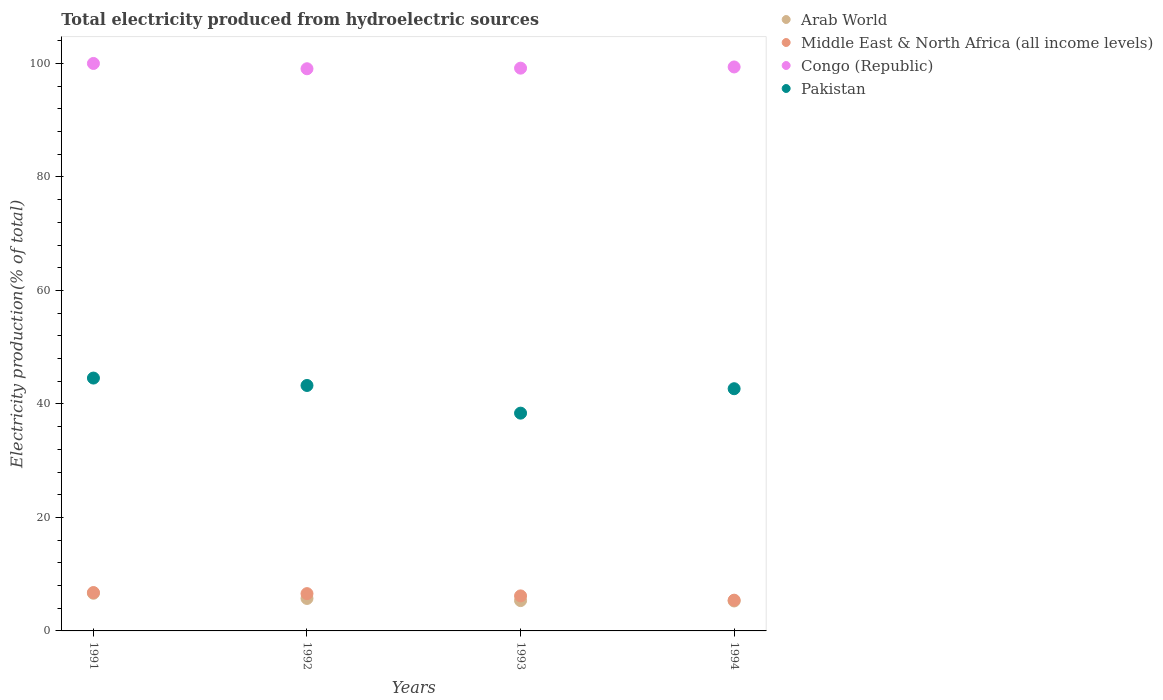How many different coloured dotlines are there?
Your answer should be very brief. 4. Is the number of dotlines equal to the number of legend labels?
Make the answer very short. Yes. What is the total electricity produced in Arab World in 1992?
Your answer should be compact. 5.72. Across all years, what is the maximum total electricity produced in Pakistan?
Ensure brevity in your answer.  44.56. Across all years, what is the minimum total electricity produced in Arab World?
Offer a very short reply. 5.28. In which year was the total electricity produced in Arab World maximum?
Make the answer very short. 1991. In which year was the total electricity produced in Middle East & North Africa (all income levels) minimum?
Ensure brevity in your answer.  1994. What is the total total electricity produced in Middle East & North Africa (all income levels) in the graph?
Offer a terse response. 24.93. What is the difference between the total electricity produced in Pakistan in 1992 and that in 1993?
Your response must be concise. 4.88. What is the difference between the total electricity produced in Congo (Republic) in 1993 and the total electricity produced in Pakistan in 1992?
Your answer should be compact. 55.92. What is the average total electricity produced in Pakistan per year?
Give a very brief answer. 42.22. In the year 1991, what is the difference between the total electricity produced in Congo (Republic) and total electricity produced in Middle East & North Africa (all income levels)?
Offer a very short reply. 93.24. What is the ratio of the total electricity produced in Middle East & North Africa (all income levels) in 1993 to that in 1994?
Offer a very short reply. 1.14. What is the difference between the highest and the second highest total electricity produced in Pakistan?
Make the answer very short. 1.31. What is the difference between the highest and the lowest total electricity produced in Congo (Republic)?
Provide a succinct answer. 0.93. In how many years, is the total electricity produced in Congo (Republic) greater than the average total electricity produced in Congo (Republic) taken over all years?
Your answer should be compact. 1. Is it the case that in every year, the sum of the total electricity produced in Pakistan and total electricity produced in Congo (Republic)  is greater than the sum of total electricity produced in Middle East & North Africa (all income levels) and total electricity produced in Arab World?
Keep it short and to the point. Yes. Is the total electricity produced in Pakistan strictly greater than the total electricity produced in Congo (Republic) over the years?
Give a very brief answer. No. How are the legend labels stacked?
Offer a terse response. Vertical. What is the title of the graph?
Your answer should be compact. Total electricity produced from hydroelectric sources. Does "Nepal" appear as one of the legend labels in the graph?
Keep it short and to the point. No. What is the label or title of the X-axis?
Your answer should be compact. Years. What is the label or title of the Y-axis?
Your answer should be compact. Electricity production(% of total). What is the Electricity production(% of total) of Arab World in 1991?
Provide a short and direct response. 6.64. What is the Electricity production(% of total) in Middle East & North Africa (all income levels) in 1991?
Offer a very short reply. 6.76. What is the Electricity production(% of total) of Pakistan in 1991?
Keep it short and to the point. 44.56. What is the Electricity production(% of total) of Arab World in 1992?
Your response must be concise. 5.72. What is the Electricity production(% of total) in Middle East & North Africa (all income levels) in 1992?
Give a very brief answer. 6.57. What is the Electricity production(% of total) of Congo (Republic) in 1992?
Provide a succinct answer. 99.07. What is the Electricity production(% of total) in Pakistan in 1992?
Provide a short and direct response. 43.25. What is the Electricity production(% of total) of Arab World in 1993?
Provide a succinct answer. 5.34. What is the Electricity production(% of total) in Middle East & North Africa (all income levels) in 1993?
Provide a succinct answer. 6.17. What is the Electricity production(% of total) of Congo (Republic) in 1993?
Keep it short and to the point. 99.17. What is the Electricity production(% of total) in Pakistan in 1993?
Keep it short and to the point. 38.38. What is the Electricity production(% of total) of Arab World in 1994?
Ensure brevity in your answer.  5.28. What is the Electricity production(% of total) in Middle East & North Africa (all income levels) in 1994?
Make the answer very short. 5.42. What is the Electricity production(% of total) in Congo (Republic) in 1994?
Provide a succinct answer. 99.38. What is the Electricity production(% of total) in Pakistan in 1994?
Make the answer very short. 42.68. Across all years, what is the maximum Electricity production(% of total) in Arab World?
Offer a very short reply. 6.64. Across all years, what is the maximum Electricity production(% of total) of Middle East & North Africa (all income levels)?
Provide a short and direct response. 6.76. Across all years, what is the maximum Electricity production(% of total) in Congo (Republic)?
Offer a very short reply. 100. Across all years, what is the maximum Electricity production(% of total) in Pakistan?
Offer a terse response. 44.56. Across all years, what is the minimum Electricity production(% of total) in Arab World?
Your answer should be very brief. 5.28. Across all years, what is the minimum Electricity production(% of total) of Middle East & North Africa (all income levels)?
Your response must be concise. 5.42. Across all years, what is the minimum Electricity production(% of total) of Congo (Republic)?
Provide a succinct answer. 99.07. Across all years, what is the minimum Electricity production(% of total) of Pakistan?
Your response must be concise. 38.38. What is the total Electricity production(% of total) of Arab World in the graph?
Give a very brief answer. 22.98. What is the total Electricity production(% of total) in Middle East & North Africa (all income levels) in the graph?
Ensure brevity in your answer.  24.93. What is the total Electricity production(% of total) in Congo (Republic) in the graph?
Keep it short and to the point. 397.62. What is the total Electricity production(% of total) of Pakistan in the graph?
Ensure brevity in your answer.  168.87. What is the difference between the Electricity production(% of total) in Arab World in 1991 and that in 1992?
Your response must be concise. 0.92. What is the difference between the Electricity production(% of total) of Middle East & North Africa (all income levels) in 1991 and that in 1992?
Give a very brief answer. 0.19. What is the difference between the Electricity production(% of total) in Congo (Republic) in 1991 and that in 1992?
Your answer should be very brief. 0.93. What is the difference between the Electricity production(% of total) of Pakistan in 1991 and that in 1992?
Provide a succinct answer. 1.31. What is the difference between the Electricity production(% of total) of Arab World in 1991 and that in 1993?
Make the answer very short. 1.3. What is the difference between the Electricity production(% of total) of Middle East & North Africa (all income levels) in 1991 and that in 1993?
Provide a succinct answer. 0.59. What is the difference between the Electricity production(% of total) in Congo (Republic) in 1991 and that in 1993?
Your answer should be compact. 0.83. What is the difference between the Electricity production(% of total) of Pakistan in 1991 and that in 1993?
Offer a terse response. 6.18. What is the difference between the Electricity production(% of total) of Arab World in 1991 and that in 1994?
Keep it short and to the point. 1.36. What is the difference between the Electricity production(% of total) in Middle East & North Africa (all income levels) in 1991 and that in 1994?
Keep it short and to the point. 1.35. What is the difference between the Electricity production(% of total) of Congo (Republic) in 1991 and that in 1994?
Provide a succinct answer. 0.62. What is the difference between the Electricity production(% of total) in Pakistan in 1991 and that in 1994?
Make the answer very short. 1.88. What is the difference between the Electricity production(% of total) in Arab World in 1992 and that in 1993?
Ensure brevity in your answer.  0.38. What is the difference between the Electricity production(% of total) of Congo (Republic) in 1992 and that in 1993?
Offer a terse response. -0.11. What is the difference between the Electricity production(% of total) of Pakistan in 1992 and that in 1993?
Offer a very short reply. 4.88. What is the difference between the Electricity production(% of total) in Arab World in 1992 and that in 1994?
Your answer should be very brief. 0.45. What is the difference between the Electricity production(% of total) in Middle East & North Africa (all income levels) in 1992 and that in 1994?
Keep it short and to the point. 1.15. What is the difference between the Electricity production(% of total) of Congo (Republic) in 1992 and that in 1994?
Provide a short and direct response. -0.32. What is the difference between the Electricity production(% of total) of Pakistan in 1992 and that in 1994?
Provide a short and direct response. 0.57. What is the difference between the Electricity production(% of total) of Arab World in 1993 and that in 1994?
Offer a terse response. 0.07. What is the difference between the Electricity production(% of total) of Middle East & North Africa (all income levels) in 1993 and that in 1994?
Make the answer very short. 0.75. What is the difference between the Electricity production(% of total) in Congo (Republic) in 1993 and that in 1994?
Your answer should be compact. -0.21. What is the difference between the Electricity production(% of total) of Pakistan in 1993 and that in 1994?
Give a very brief answer. -4.31. What is the difference between the Electricity production(% of total) in Arab World in 1991 and the Electricity production(% of total) in Middle East & North Africa (all income levels) in 1992?
Offer a very short reply. 0.07. What is the difference between the Electricity production(% of total) in Arab World in 1991 and the Electricity production(% of total) in Congo (Republic) in 1992?
Your response must be concise. -92.43. What is the difference between the Electricity production(% of total) in Arab World in 1991 and the Electricity production(% of total) in Pakistan in 1992?
Keep it short and to the point. -36.61. What is the difference between the Electricity production(% of total) of Middle East & North Africa (all income levels) in 1991 and the Electricity production(% of total) of Congo (Republic) in 1992?
Your response must be concise. -92.3. What is the difference between the Electricity production(% of total) in Middle East & North Africa (all income levels) in 1991 and the Electricity production(% of total) in Pakistan in 1992?
Provide a succinct answer. -36.49. What is the difference between the Electricity production(% of total) in Congo (Republic) in 1991 and the Electricity production(% of total) in Pakistan in 1992?
Ensure brevity in your answer.  56.75. What is the difference between the Electricity production(% of total) of Arab World in 1991 and the Electricity production(% of total) of Middle East & North Africa (all income levels) in 1993?
Your answer should be very brief. 0.47. What is the difference between the Electricity production(% of total) of Arab World in 1991 and the Electricity production(% of total) of Congo (Republic) in 1993?
Offer a very short reply. -92.53. What is the difference between the Electricity production(% of total) in Arab World in 1991 and the Electricity production(% of total) in Pakistan in 1993?
Make the answer very short. -31.74. What is the difference between the Electricity production(% of total) in Middle East & North Africa (all income levels) in 1991 and the Electricity production(% of total) in Congo (Republic) in 1993?
Offer a very short reply. -92.41. What is the difference between the Electricity production(% of total) in Middle East & North Africa (all income levels) in 1991 and the Electricity production(% of total) in Pakistan in 1993?
Offer a very short reply. -31.61. What is the difference between the Electricity production(% of total) of Congo (Republic) in 1991 and the Electricity production(% of total) of Pakistan in 1993?
Your answer should be very brief. 61.62. What is the difference between the Electricity production(% of total) in Arab World in 1991 and the Electricity production(% of total) in Middle East & North Africa (all income levels) in 1994?
Offer a terse response. 1.22. What is the difference between the Electricity production(% of total) in Arab World in 1991 and the Electricity production(% of total) in Congo (Republic) in 1994?
Offer a very short reply. -92.74. What is the difference between the Electricity production(% of total) of Arab World in 1991 and the Electricity production(% of total) of Pakistan in 1994?
Ensure brevity in your answer.  -36.04. What is the difference between the Electricity production(% of total) of Middle East & North Africa (all income levels) in 1991 and the Electricity production(% of total) of Congo (Republic) in 1994?
Give a very brief answer. -92.62. What is the difference between the Electricity production(% of total) of Middle East & North Africa (all income levels) in 1991 and the Electricity production(% of total) of Pakistan in 1994?
Your answer should be very brief. -35.92. What is the difference between the Electricity production(% of total) of Congo (Republic) in 1991 and the Electricity production(% of total) of Pakistan in 1994?
Your response must be concise. 57.32. What is the difference between the Electricity production(% of total) of Arab World in 1992 and the Electricity production(% of total) of Middle East & North Africa (all income levels) in 1993?
Offer a terse response. -0.45. What is the difference between the Electricity production(% of total) of Arab World in 1992 and the Electricity production(% of total) of Congo (Republic) in 1993?
Offer a terse response. -93.45. What is the difference between the Electricity production(% of total) of Arab World in 1992 and the Electricity production(% of total) of Pakistan in 1993?
Your answer should be very brief. -32.65. What is the difference between the Electricity production(% of total) in Middle East & North Africa (all income levels) in 1992 and the Electricity production(% of total) in Congo (Republic) in 1993?
Your answer should be compact. -92.6. What is the difference between the Electricity production(% of total) in Middle East & North Africa (all income levels) in 1992 and the Electricity production(% of total) in Pakistan in 1993?
Give a very brief answer. -31.8. What is the difference between the Electricity production(% of total) of Congo (Republic) in 1992 and the Electricity production(% of total) of Pakistan in 1993?
Make the answer very short. 60.69. What is the difference between the Electricity production(% of total) of Arab World in 1992 and the Electricity production(% of total) of Middle East & North Africa (all income levels) in 1994?
Provide a succinct answer. 0.3. What is the difference between the Electricity production(% of total) of Arab World in 1992 and the Electricity production(% of total) of Congo (Republic) in 1994?
Offer a very short reply. -93.66. What is the difference between the Electricity production(% of total) in Arab World in 1992 and the Electricity production(% of total) in Pakistan in 1994?
Your response must be concise. -36.96. What is the difference between the Electricity production(% of total) of Middle East & North Africa (all income levels) in 1992 and the Electricity production(% of total) of Congo (Republic) in 1994?
Offer a very short reply. -92.81. What is the difference between the Electricity production(% of total) of Middle East & North Africa (all income levels) in 1992 and the Electricity production(% of total) of Pakistan in 1994?
Provide a succinct answer. -36.11. What is the difference between the Electricity production(% of total) in Congo (Republic) in 1992 and the Electricity production(% of total) in Pakistan in 1994?
Offer a terse response. 56.38. What is the difference between the Electricity production(% of total) of Arab World in 1993 and the Electricity production(% of total) of Middle East & North Africa (all income levels) in 1994?
Ensure brevity in your answer.  -0.08. What is the difference between the Electricity production(% of total) of Arab World in 1993 and the Electricity production(% of total) of Congo (Republic) in 1994?
Make the answer very short. -94.04. What is the difference between the Electricity production(% of total) of Arab World in 1993 and the Electricity production(% of total) of Pakistan in 1994?
Provide a succinct answer. -37.34. What is the difference between the Electricity production(% of total) in Middle East & North Africa (all income levels) in 1993 and the Electricity production(% of total) in Congo (Republic) in 1994?
Provide a succinct answer. -93.21. What is the difference between the Electricity production(% of total) in Middle East & North Africa (all income levels) in 1993 and the Electricity production(% of total) in Pakistan in 1994?
Give a very brief answer. -36.51. What is the difference between the Electricity production(% of total) of Congo (Republic) in 1993 and the Electricity production(% of total) of Pakistan in 1994?
Offer a terse response. 56.49. What is the average Electricity production(% of total) of Arab World per year?
Give a very brief answer. 5.75. What is the average Electricity production(% of total) of Middle East & North Africa (all income levels) per year?
Offer a terse response. 6.23. What is the average Electricity production(% of total) of Congo (Republic) per year?
Provide a short and direct response. 99.4. What is the average Electricity production(% of total) of Pakistan per year?
Offer a very short reply. 42.22. In the year 1991, what is the difference between the Electricity production(% of total) in Arab World and Electricity production(% of total) in Middle East & North Africa (all income levels)?
Keep it short and to the point. -0.13. In the year 1991, what is the difference between the Electricity production(% of total) in Arab World and Electricity production(% of total) in Congo (Republic)?
Ensure brevity in your answer.  -93.36. In the year 1991, what is the difference between the Electricity production(% of total) in Arab World and Electricity production(% of total) in Pakistan?
Offer a terse response. -37.92. In the year 1991, what is the difference between the Electricity production(% of total) in Middle East & North Africa (all income levels) and Electricity production(% of total) in Congo (Republic)?
Your answer should be very brief. -93.24. In the year 1991, what is the difference between the Electricity production(% of total) in Middle East & North Africa (all income levels) and Electricity production(% of total) in Pakistan?
Your answer should be very brief. -37.79. In the year 1991, what is the difference between the Electricity production(% of total) in Congo (Republic) and Electricity production(% of total) in Pakistan?
Ensure brevity in your answer.  55.44. In the year 1992, what is the difference between the Electricity production(% of total) in Arab World and Electricity production(% of total) in Middle East & North Africa (all income levels)?
Your response must be concise. -0.85. In the year 1992, what is the difference between the Electricity production(% of total) in Arab World and Electricity production(% of total) in Congo (Republic)?
Offer a very short reply. -93.34. In the year 1992, what is the difference between the Electricity production(% of total) of Arab World and Electricity production(% of total) of Pakistan?
Provide a short and direct response. -37.53. In the year 1992, what is the difference between the Electricity production(% of total) of Middle East & North Africa (all income levels) and Electricity production(% of total) of Congo (Republic)?
Provide a succinct answer. -92.49. In the year 1992, what is the difference between the Electricity production(% of total) of Middle East & North Africa (all income levels) and Electricity production(% of total) of Pakistan?
Your answer should be compact. -36.68. In the year 1992, what is the difference between the Electricity production(% of total) in Congo (Republic) and Electricity production(% of total) in Pakistan?
Make the answer very short. 55.81. In the year 1993, what is the difference between the Electricity production(% of total) of Arab World and Electricity production(% of total) of Middle East & North Africa (all income levels)?
Offer a terse response. -0.83. In the year 1993, what is the difference between the Electricity production(% of total) of Arab World and Electricity production(% of total) of Congo (Republic)?
Give a very brief answer. -93.83. In the year 1993, what is the difference between the Electricity production(% of total) in Arab World and Electricity production(% of total) in Pakistan?
Give a very brief answer. -33.03. In the year 1993, what is the difference between the Electricity production(% of total) of Middle East & North Africa (all income levels) and Electricity production(% of total) of Congo (Republic)?
Your answer should be compact. -93. In the year 1993, what is the difference between the Electricity production(% of total) of Middle East & North Africa (all income levels) and Electricity production(% of total) of Pakistan?
Ensure brevity in your answer.  -32.2. In the year 1993, what is the difference between the Electricity production(% of total) of Congo (Republic) and Electricity production(% of total) of Pakistan?
Your answer should be compact. 60.8. In the year 1994, what is the difference between the Electricity production(% of total) of Arab World and Electricity production(% of total) of Middle East & North Africa (all income levels)?
Your response must be concise. -0.14. In the year 1994, what is the difference between the Electricity production(% of total) of Arab World and Electricity production(% of total) of Congo (Republic)?
Give a very brief answer. -94.11. In the year 1994, what is the difference between the Electricity production(% of total) of Arab World and Electricity production(% of total) of Pakistan?
Give a very brief answer. -37.4. In the year 1994, what is the difference between the Electricity production(% of total) of Middle East & North Africa (all income levels) and Electricity production(% of total) of Congo (Republic)?
Offer a very short reply. -93.96. In the year 1994, what is the difference between the Electricity production(% of total) of Middle East & North Africa (all income levels) and Electricity production(% of total) of Pakistan?
Your answer should be compact. -37.26. In the year 1994, what is the difference between the Electricity production(% of total) in Congo (Republic) and Electricity production(% of total) in Pakistan?
Provide a succinct answer. 56.7. What is the ratio of the Electricity production(% of total) in Arab World in 1991 to that in 1992?
Offer a terse response. 1.16. What is the ratio of the Electricity production(% of total) in Middle East & North Africa (all income levels) in 1991 to that in 1992?
Your answer should be compact. 1.03. What is the ratio of the Electricity production(% of total) of Congo (Republic) in 1991 to that in 1992?
Make the answer very short. 1.01. What is the ratio of the Electricity production(% of total) in Pakistan in 1991 to that in 1992?
Keep it short and to the point. 1.03. What is the ratio of the Electricity production(% of total) of Arab World in 1991 to that in 1993?
Ensure brevity in your answer.  1.24. What is the ratio of the Electricity production(% of total) in Middle East & North Africa (all income levels) in 1991 to that in 1993?
Your answer should be very brief. 1.1. What is the ratio of the Electricity production(% of total) in Congo (Republic) in 1991 to that in 1993?
Offer a very short reply. 1.01. What is the ratio of the Electricity production(% of total) of Pakistan in 1991 to that in 1993?
Offer a very short reply. 1.16. What is the ratio of the Electricity production(% of total) in Arab World in 1991 to that in 1994?
Provide a short and direct response. 1.26. What is the ratio of the Electricity production(% of total) in Middle East & North Africa (all income levels) in 1991 to that in 1994?
Your answer should be very brief. 1.25. What is the ratio of the Electricity production(% of total) in Pakistan in 1991 to that in 1994?
Give a very brief answer. 1.04. What is the ratio of the Electricity production(% of total) of Arab World in 1992 to that in 1993?
Ensure brevity in your answer.  1.07. What is the ratio of the Electricity production(% of total) of Middle East & North Africa (all income levels) in 1992 to that in 1993?
Offer a terse response. 1.06. What is the ratio of the Electricity production(% of total) in Pakistan in 1992 to that in 1993?
Keep it short and to the point. 1.13. What is the ratio of the Electricity production(% of total) in Arab World in 1992 to that in 1994?
Keep it short and to the point. 1.08. What is the ratio of the Electricity production(% of total) in Middle East & North Africa (all income levels) in 1992 to that in 1994?
Offer a very short reply. 1.21. What is the ratio of the Electricity production(% of total) in Congo (Republic) in 1992 to that in 1994?
Make the answer very short. 1. What is the ratio of the Electricity production(% of total) in Pakistan in 1992 to that in 1994?
Provide a short and direct response. 1.01. What is the ratio of the Electricity production(% of total) in Arab World in 1993 to that in 1994?
Offer a terse response. 1.01. What is the ratio of the Electricity production(% of total) of Middle East & North Africa (all income levels) in 1993 to that in 1994?
Your answer should be very brief. 1.14. What is the ratio of the Electricity production(% of total) in Pakistan in 1993 to that in 1994?
Provide a short and direct response. 0.9. What is the difference between the highest and the second highest Electricity production(% of total) of Arab World?
Provide a succinct answer. 0.92. What is the difference between the highest and the second highest Electricity production(% of total) in Middle East & North Africa (all income levels)?
Your answer should be compact. 0.19. What is the difference between the highest and the second highest Electricity production(% of total) in Congo (Republic)?
Your response must be concise. 0.62. What is the difference between the highest and the second highest Electricity production(% of total) in Pakistan?
Your response must be concise. 1.31. What is the difference between the highest and the lowest Electricity production(% of total) in Arab World?
Give a very brief answer. 1.36. What is the difference between the highest and the lowest Electricity production(% of total) in Middle East & North Africa (all income levels)?
Your answer should be compact. 1.35. What is the difference between the highest and the lowest Electricity production(% of total) in Congo (Republic)?
Give a very brief answer. 0.93. What is the difference between the highest and the lowest Electricity production(% of total) of Pakistan?
Your answer should be compact. 6.18. 